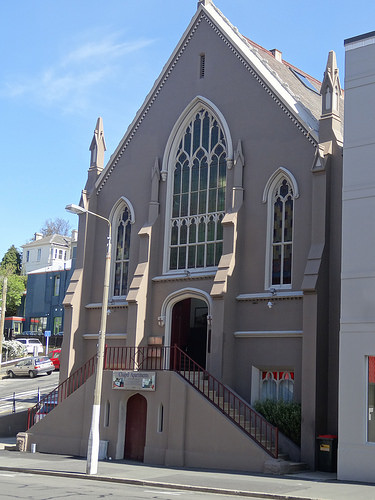<image>
Is there a light pole in the building? No. The light pole is not contained within the building. These objects have a different spatial relationship. 